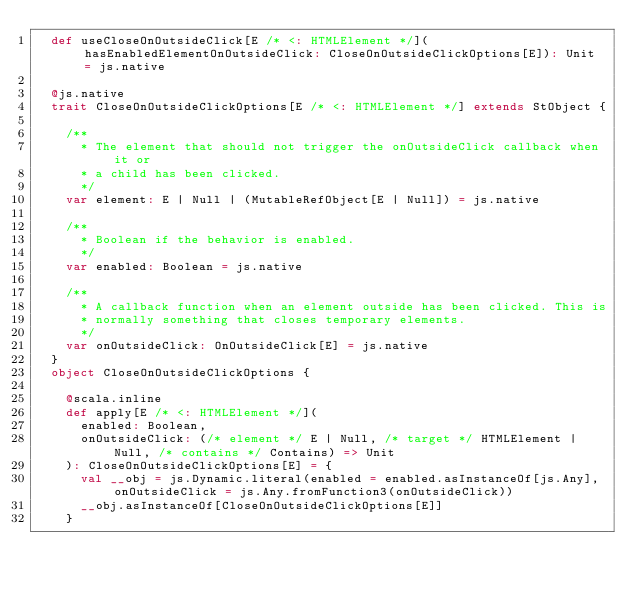<code> <loc_0><loc_0><loc_500><loc_500><_Scala_>  def useCloseOnOutsideClick[E /* <: HTMLElement */](hasEnabledElementOnOutsideClick: CloseOnOutsideClickOptions[E]): Unit = js.native
  
  @js.native
  trait CloseOnOutsideClickOptions[E /* <: HTMLElement */] extends StObject {
    
    /**
      * The element that should not trigger the onOutsideClick callback when it or
      * a child has been clicked.
      */
    var element: E | Null | (MutableRefObject[E | Null]) = js.native
    
    /**
      * Boolean if the behavior is enabled.
      */
    var enabled: Boolean = js.native
    
    /**
      * A callback function when an element outside has been clicked. This is
      * normally something that closes temporary elements.
      */
    var onOutsideClick: OnOutsideClick[E] = js.native
  }
  object CloseOnOutsideClickOptions {
    
    @scala.inline
    def apply[E /* <: HTMLElement */](
      enabled: Boolean,
      onOutsideClick: (/* element */ E | Null, /* target */ HTMLElement | Null, /* contains */ Contains) => Unit
    ): CloseOnOutsideClickOptions[E] = {
      val __obj = js.Dynamic.literal(enabled = enabled.asInstanceOf[js.Any], onOutsideClick = js.Any.fromFunction3(onOutsideClick))
      __obj.asInstanceOf[CloseOnOutsideClickOptions[E]]
    }
    </code> 